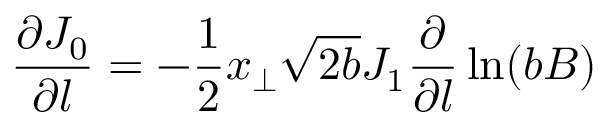Convert formula to latex. <formula><loc_0><loc_0><loc_500><loc_500>\frac { \partial J _ { 0 } } { \partial l } = - \frac { 1 } { 2 } x _ { \perp } \sqrt { 2 b } J _ { 1 } \frac { \partial } { \partial l } \ln ( b B )</formula> 